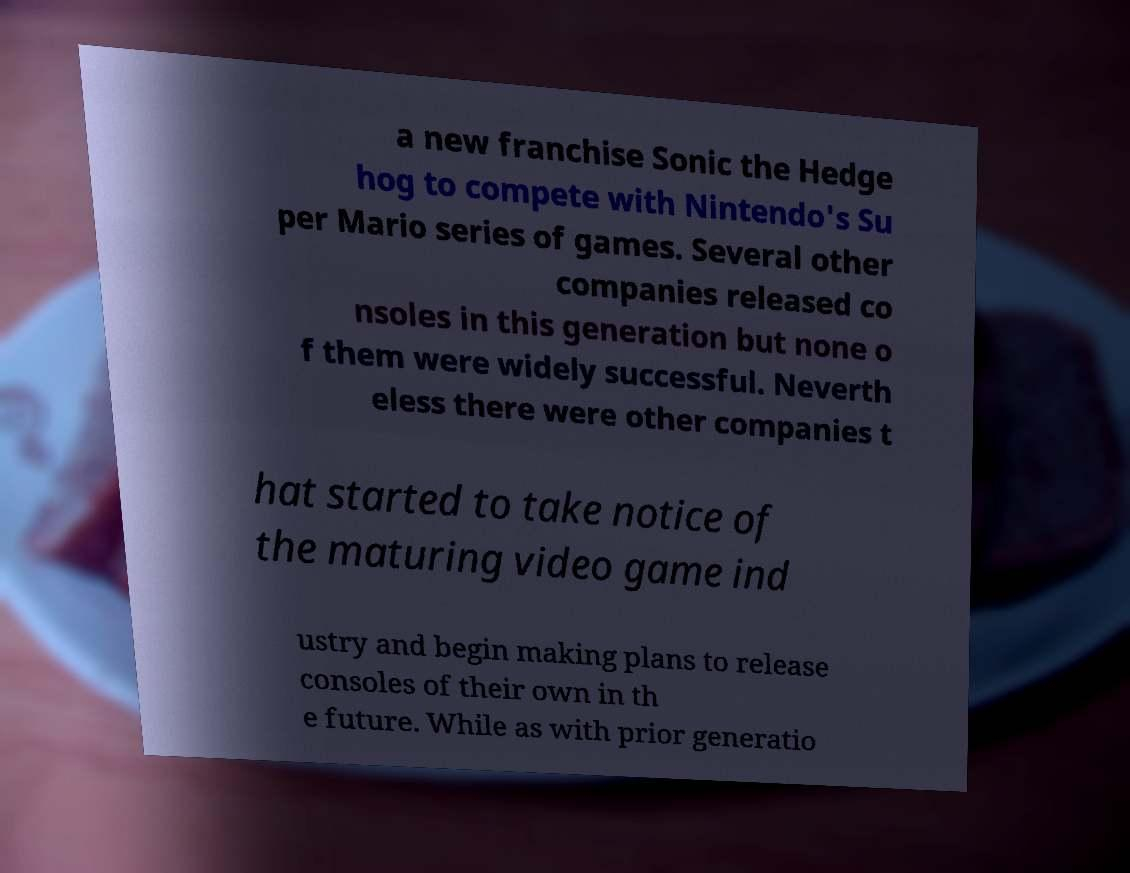Please identify and transcribe the text found in this image. a new franchise Sonic the Hedge hog to compete with Nintendo's Su per Mario series of games. Several other companies released co nsoles in this generation but none o f them were widely successful. Neverth eless there were other companies t hat started to take notice of the maturing video game ind ustry and begin making plans to release consoles of their own in th e future. While as with prior generatio 